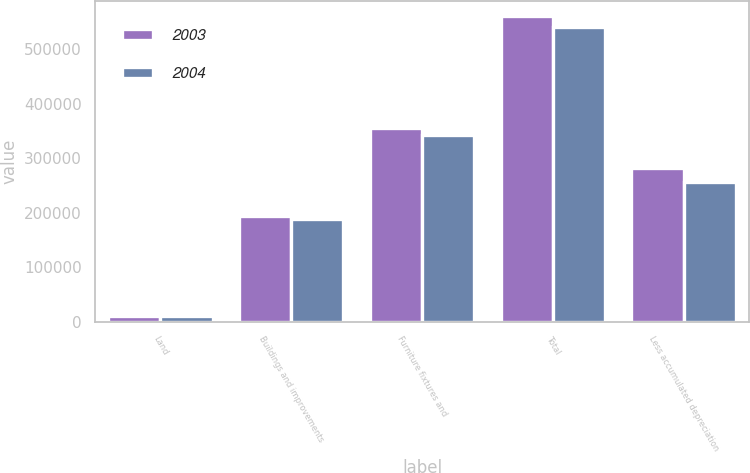<chart> <loc_0><loc_0><loc_500><loc_500><stacked_bar_chart><ecel><fcel>Land<fcel>Buildings and improvements<fcel>Furniture fixtures and<fcel>Total<fcel>Less accumulated depreciation<nl><fcel>2003<fcel>10831<fcel>193586<fcel>355248<fcel>559665<fcel>282577<nl><fcel>2004<fcel>10781<fcel>187375<fcel>341474<fcel>539630<fcel>255868<nl></chart> 